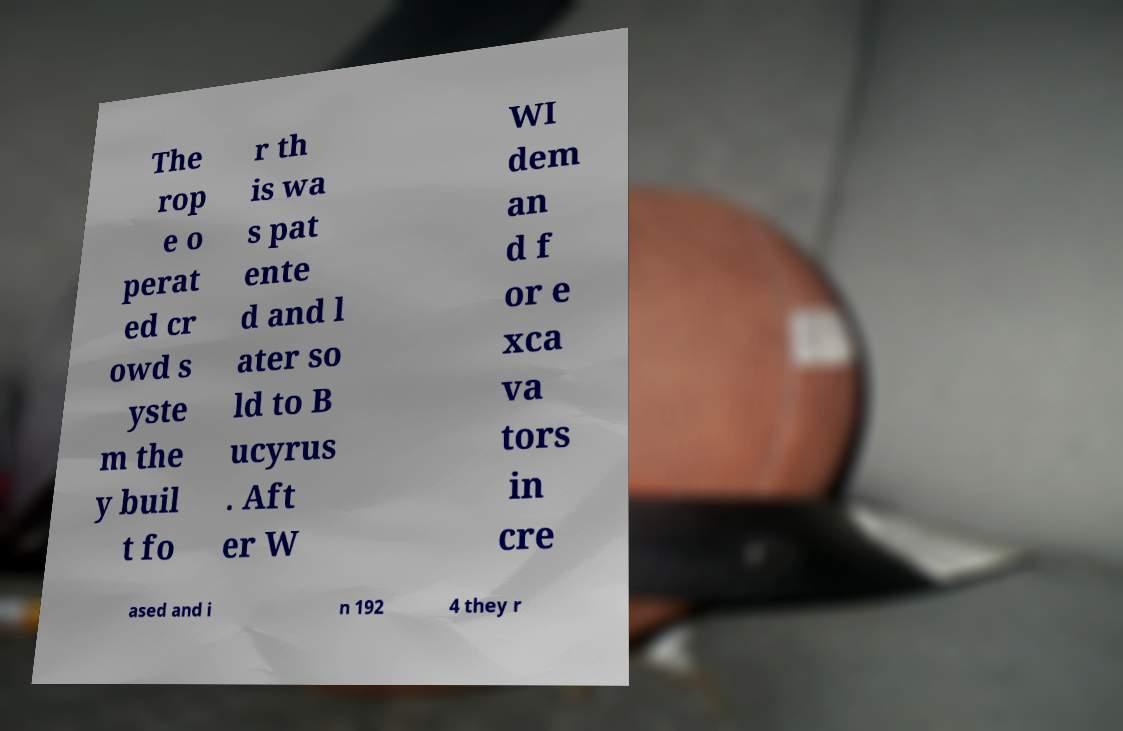There's text embedded in this image that I need extracted. Can you transcribe it verbatim? The rop e o perat ed cr owd s yste m the y buil t fo r th is wa s pat ente d and l ater so ld to B ucyrus . Aft er W WI dem an d f or e xca va tors in cre ased and i n 192 4 they r 